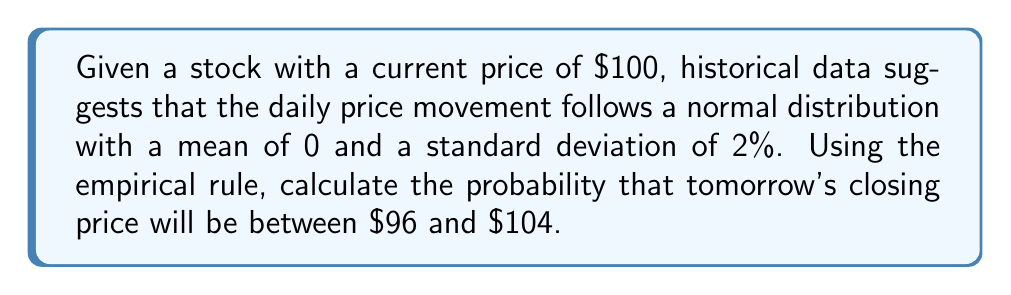Help me with this question. Let's approach this step-by-step:

1) First, we need to convert the price range into standard deviations. The formula for z-score is:

   $$ z = \frac{x - \mu}{\sigma} $$

   Where $x$ is the price, $\mu$ is the mean, and $\sigma$ is the standard deviation.

2) For the lower bound ($96):
   $$ z_{lower} = \frac{96 - 100}{100 * 0.02} = -2 $$

3) For the upper bound ($104):
   $$ z_{upper} = \frac{104 - 100}{100 * 0.02} = 2 $$

4) Now, we can use the empirical rule (68-95-99.7 rule) for normal distributions:
   - 68% of data falls within 1 standard deviation
   - 95% of data falls within 2 standard deviations
   - 99.7% of data falls within 3 standard deviations

5) Our z-scores (-2 to 2) correspond to 2 standard deviations on either side of the mean.

6) Therefore, the probability that tomorrow's closing price will be between $96 and $104 is 95%.
Answer: 95% 